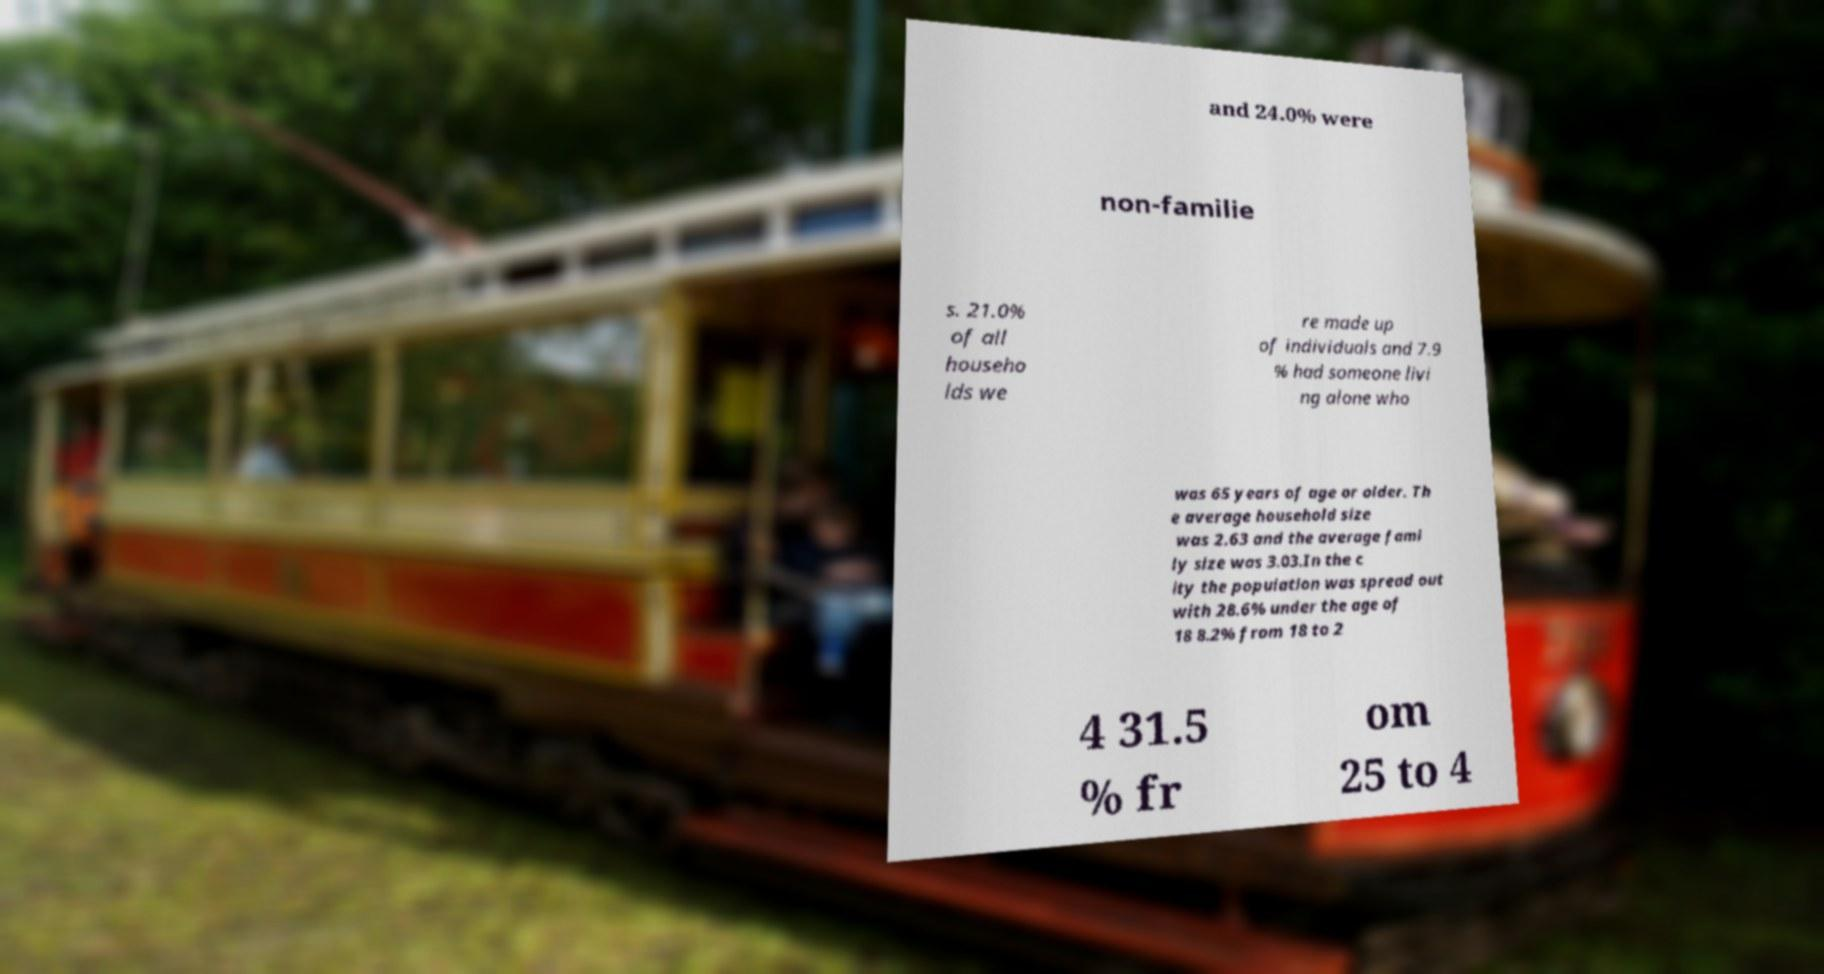Could you extract and type out the text from this image? and 24.0% were non-familie s. 21.0% of all househo lds we re made up of individuals and 7.9 % had someone livi ng alone who was 65 years of age or older. Th e average household size was 2.63 and the average fami ly size was 3.03.In the c ity the population was spread out with 28.6% under the age of 18 8.2% from 18 to 2 4 31.5 % fr om 25 to 4 